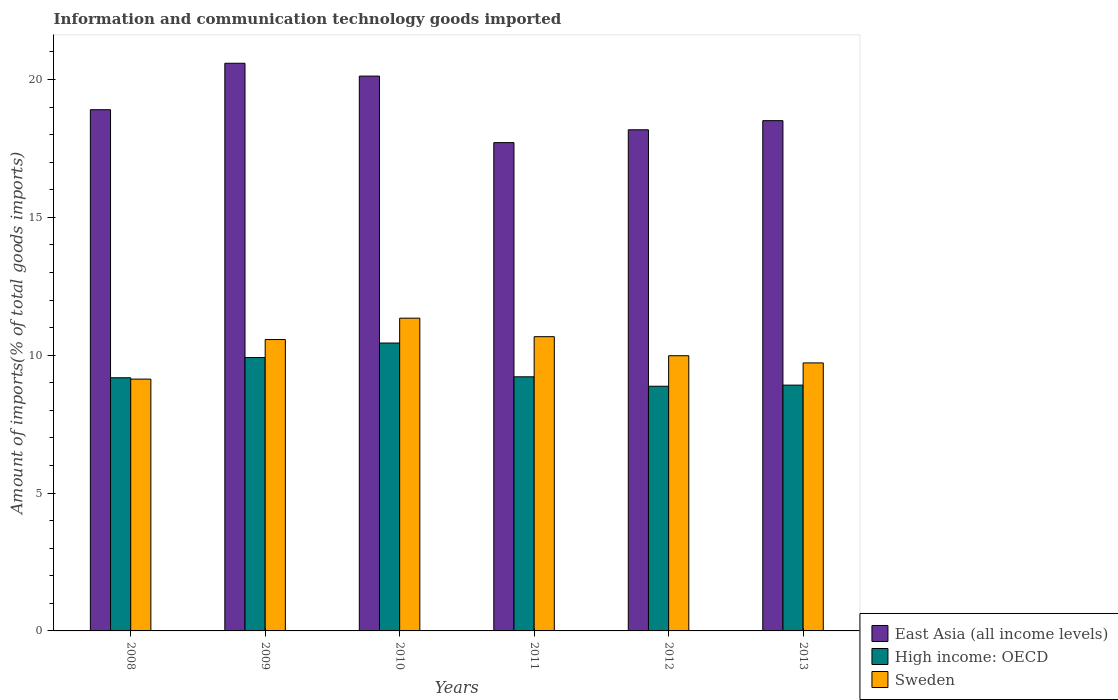How many groups of bars are there?
Offer a terse response. 6. Are the number of bars per tick equal to the number of legend labels?
Your answer should be compact. Yes. How many bars are there on the 2nd tick from the left?
Give a very brief answer. 3. What is the label of the 6th group of bars from the left?
Keep it short and to the point. 2013. In how many cases, is the number of bars for a given year not equal to the number of legend labels?
Provide a succinct answer. 0. What is the amount of goods imported in High income: OECD in 2013?
Offer a very short reply. 8.92. Across all years, what is the maximum amount of goods imported in Sweden?
Provide a succinct answer. 11.34. Across all years, what is the minimum amount of goods imported in High income: OECD?
Offer a very short reply. 8.87. In which year was the amount of goods imported in East Asia (all income levels) minimum?
Keep it short and to the point. 2011. What is the total amount of goods imported in High income: OECD in the graph?
Make the answer very short. 56.55. What is the difference between the amount of goods imported in Sweden in 2012 and that in 2013?
Make the answer very short. 0.26. What is the difference between the amount of goods imported in Sweden in 2011 and the amount of goods imported in High income: OECD in 2008?
Offer a very short reply. 1.49. What is the average amount of goods imported in Sweden per year?
Make the answer very short. 10.24. In the year 2013, what is the difference between the amount of goods imported in Sweden and amount of goods imported in East Asia (all income levels)?
Offer a very short reply. -8.79. In how many years, is the amount of goods imported in High income: OECD greater than 20 %?
Your answer should be compact. 0. What is the ratio of the amount of goods imported in East Asia (all income levels) in 2008 to that in 2011?
Provide a succinct answer. 1.07. Is the difference between the amount of goods imported in Sweden in 2011 and 2012 greater than the difference between the amount of goods imported in East Asia (all income levels) in 2011 and 2012?
Provide a short and direct response. Yes. What is the difference between the highest and the second highest amount of goods imported in East Asia (all income levels)?
Your response must be concise. 0.47. What is the difference between the highest and the lowest amount of goods imported in High income: OECD?
Provide a succinct answer. 1.57. What does the 1st bar from the left in 2010 represents?
Offer a very short reply. East Asia (all income levels). What does the 3rd bar from the right in 2012 represents?
Give a very brief answer. East Asia (all income levels). Is it the case that in every year, the sum of the amount of goods imported in High income: OECD and amount of goods imported in East Asia (all income levels) is greater than the amount of goods imported in Sweden?
Provide a succinct answer. Yes. Are all the bars in the graph horizontal?
Make the answer very short. No. How many years are there in the graph?
Give a very brief answer. 6. Does the graph contain grids?
Offer a very short reply. No. How many legend labels are there?
Your answer should be compact. 3. How are the legend labels stacked?
Offer a terse response. Vertical. What is the title of the graph?
Give a very brief answer. Information and communication technology goods imported. What is the label or title of the Y-axis?
Offer a very short reply. Amount of imports(% of total goods imports). What is the Amount of imports(% of total goods imports) of East Asia (all income levels) in 2008?
Your answer should be very brief. 18.9. What is the Amount of imports(% of total goods imports) of High income: OECD in 2008?
Provide a short and direct response. 9.18. What is the Amount of imports(% of total goods imports) in Sweden in 2008?
Your answer should be compact. 9.13. What is the Amount of imports(% of total goods imports) in East Asia (all income levels) in 2009?
Your response must be concise. 20.59. What is the Amount of imports(% of total goods imports) in High income: OECD in 2009?
Make the answer very short. 9.92. What is the Amount of imports(% of total goods imports) in Sweden in 2009?
Make the answer very short. 10.57. What is the Amount of imports(% of total goods imports) of East Asia (all income levels) in 2010?
Give a very brief answer. 20.12. What is the Amount of imports(% of total goods imports) in High income: OECD in 2010?
Offer a terse response. 10.44. What is the Amount of imports(% of total goods imports) in Sweden in 2010?
Your answer should be compact. 11.34. What is the Amount of imports(% of total goods imports) of East Asia (all income levels) in 2011?
Make the answer very short. 17.71. What is the Amount of imports(% of total goods imports) of High income: OECD in 2011?
Offer a terse response. 9.22. What is the Amount of imports(% of total goods imports) in Sweden in 2011?
Your answer should be compact. 10.67. What is the Amount of imports(% of total goods imports) of East Asia (all income levels) in 2012?
Your answer should be very brief. 18.18. What is the Amount of imports(% of total goods imports) in High income: OECD in 2012?
Your answer should be compact. 8.87. What is the Amount of imports(% of total goods imports) of Sweden in 2012?
Your response must be concise. 9.98. What is the Amount of imports(% of total goods imports) in East Asia (all income levels) in 2013?
Provide a succinct answer. 18.51. What is the Amount of imports(% of total goods imports) of High income: OECD in 2013?
Your response must be concise. 8.92. What is the Amount of imports(% of total goods imports) in Sweden in 2013?
Your answer should be compact. 9.72. Across all years, what is the maximum Amount of imports(% of total goods imports) in East Asia (all income levels)?
Provide a succinct answer. 20.59. Across all years, what is the maximum Amount of imports(% of total goods imports) in High income: OECD?
Give a very brief answer. 10.44. Across all years, what is the maximum Amount of imports(% of total goods imports) of Sweden?
Offer a terse response. 11.34. Across all years, what is the minimum Amount of imports(% of total goods imports) in East Asia (all income levels)?
Ensure brevity in your answer.  17.71. Across all years, what is the minimum Amount of imports(% of total goods imports) of High income: OECD?
Give a very brief answer. 8.87. Across all years, what is the minimum Amount of imports(% of total goods imports) in Sweden?
Make the answer very short. 9.13. What is the total Amount of imports(% of total goods imports) of East Asia (all income levels) in the graph?
Give a very brief answer. 114.02. What is the total Amount of imports(% of total goods imports) of High income: OECD in the graph?
Ensure brevity in your answer.  56.55. What is the total Amount of imports(% of total goods imports) of Sweden in the graph?
Provide a short and direct response. 61.42. What is the difference between the Amount of imports(% of total goods imports) of East Asia (all income levels) in 2008 and that in 2009?
Give a very brief answer. -1.68. What is the difference between the Amount of imports(% of total goods imports) of High income: OECD in 2008 and that in 2009?
Provide a succinct answer. -0.73. What is the difference between the Amount of imports(% of total goods imports) in Sweden in 2008 and that in 2009?
Offer a terse response. -1.44. What is the difference between the Amount of imports(% of total goods imports) in East Asia (all income levels) in 2008 and that in 2010?
Keep it short and to the point. -1.22. What is the difference between the Amount of imports(% of total goods imports) in High income: OECD in 2008 and that in 2010?
Make the answer very short. -1.26. What is the difference between the Amount of imports(% of total goods imports) of Sweden in 2008 and that in 2010?
Provide a short and direct response. -2.21. What is the difference between the Amount of imports(% of total goods imports) of East Asia (all income levels) in 2008 and that in 2011?
Offer a terse response. 1.19. What is the difference between the Amount of imports(% of total goods imports) of High income: OECD in 2008 and that in 2011?
Give a very brief answer. -0.03. What is the difference between the Amount of imports(% of total goods imports) of Sweden in 2008 and that in 2011?
Your answer should be compact. -1.54. What is the difference between the Amount of imports(% of total goods imports) in East Asia (all income levels) in 2008 and that in 2012?
Offer a terse response. 0.73. What is the difference between the Amount of imports(% of total goods imports) of High income: OECD in 2008 and that in 2012?
Your answer should be very brief. 0.31. What is the difference between the Amount of imports(% of total goods imports) in Sweden in 2008 and that in 2012?
Provide a short and direct response. -0.85. What is the difference between the Amount of imports(% of total goods imports) of East Asia (all income levels) in 2008 and that in 2013?
Keep it short and to the point. 0.4. What is the difference between the Amount of imports(% of total goods imports) in High income: OECD in 2008 and that in 2013?
Your answer should be very brief. 0.27. What is the difference between the Amount of imports(% of total goods imports) in Sweden in 2008 and that in 2013?
Give a very brief answer. -0.59. What is the difference between the Amount of imports(% of total goods imports) in East Asia (all income levels) in 2009 and that in 2010?
Offer a very short reply. 0.47. What is the difference between the Amount of imports(% of total goods imports) in High income: OECD in 2009 and that in 2010?
Your answer should be compact. -0.53. What is the difference between the Amount of imports(% of total goods imports) in Sweden in 2009 and that in 2010?
Offer a terse response. -0.78. What is the difference between the Amount of imports(% of total goods imports) of East Asia (all income levels) in 2009 and that in 2011?
Offer a very short reply. 2.88. What is the difference between the Amount of imports(% of total goods imports) of High income: OECD in 2009 and that in 2011?
Your response must be concise. 0.7. What is the difference between the Amount of imports(% of total goods imports) in Sweden in 2009 and that in 2011?
Your response must be concise. -0.1. What is the difference between the Amount of imports(% of total goods imports) in East Asia (all income levels) in 2009 and that in 2012?
Ensure brevity in your answer.  2.41. What is the difference between the Amount of imports(% of total goods imports) of High income: OECD in 2009 and that in 2012?
Your answer should be very brief. 1.04. What is the difference between the Amount of imports(% of total goods imports) in Sweden in 2009 and that in 2012?
Provide a short and direct response. 0.59. What is the difference between the Amount of imports(% of total goods imports) of East Asia (all income levels) in 2009 and that in 2013?
Provide a short and direct response. 2.08. What is the difference between the Amount of imports(% of total goods imports) in Sweden in 2009 and that in 2013?
Keep it short and to the point. 0.85. What is the difference between the Amount of imports(% of total goods imports) in East Asia (all income levels) in 2010 and that in 2011?
Make the answer very short. 2.41. What is the difference between the Amount of imports(% of total goods imports) in High income: OECD in 2010 and that in 2011?
Make the answer very short. 1.22. What is the difference between the Amount of imports(% of total goods imports) of Sweden in 2010 and that in 2011?
Provide a short and direct response. 0.67. What is the difference between the Amount of imports(% of total goods imports) of East Asia (all income levels) in 2010 and that in 2012?
Offer a terse response. 1.95. What is the difference between the Amount of imports(% of total goods imports) of High income: OECD in 2010 and that in 2012?
Offer a very short reply. 1.57. What is the difference between the Amount of imports(% of total goods imports) of Sweden in 2010 and that in 2012?
Provide a succinct answer. 1.36. What is the difference between the Amount of imports(% of total goods imports) of East Asia (all income levels) in 2010 and that in 2013?
Offer a terse response. 1.62. What is the difference between the Amount of imports(% of total goods imports) in High income: OECD in 2010 and that in 2013?
Give a very brief answer. 1.53. What is the difference between the Amount of imports(% of total goods imports) of Sweden in 2010 and that in 2013?
Ensure brevity in your answer.  1.62. What is the difference between the Amount of imports(% of total goods imports) in East Asia (all income levels) in 2011 and that in 2012?
Offer a very short reply. -0.47. What is the difference between the Amount of imports(% of total goods imports) in High income: OECD in 2011 and that in 2012?
Offer a terse response. 0.34. What is the difference between the Amount of imports(% of total goods imports) of Sweden in 2011 and that in 2012?
Offer a terse response. 0.69. What is the difference between the Amount of imports(% of total goods imports) in East Asia (all income levels) in 2011 and that in 2013?
Provide a succinct answer. -0.8. What is the difference between the Amount of imports(% of total goods imports) of High income: OECD in 2011 and that in 2013?
Make the answer very short. 0.3. What is the difference between the Amount of imports(% of total goods imports) in Sweden in 2011 and that in 2013?
Offer a terse response. 0.95. What is the difference between the Amount of imports(% of total goods imports) in East Asia (all income levels) in 2012 and that in 2013?
Make the answer very short. -0.33. What is the difference between the Amount of imports(% of total goods imports) in High income: OECD in 2012 and that in 2013?
Give a very brief answer. -0.04. What is the difference between the Amount of imports(% of total goods imports) of Sweden in 2012 and that in 2013?
Your answer should be compact. 0.26. What is the difference between the Amount of imports(% of total goods imports) of East Asia (all income levels) in 2008 and the Amount of imports(% of total goods imports) of High income: OECD in 2009?
Ensure brevity in your answer.  8.99. What is the difference between the Amount of imports(% of total goods imports) of East Asia (all income levels) in 2008 and the Amount of imports(% of total goods imports) of Sweden in 2009?
Make the answer very short. 8.34. What is the difference between the Amount of imports(% of total goods imports) in High income: OECD in 2008 and the Amount of imports(% of total goods imports) in Sweden in 2009?
Your answer should be compact. -1.39. What is the difference between the Amount of imports(% of total goods imports) of East Asia (all income levels) in 2008 and the Amount of imports(% of total goods imports) of High income: OECD in 2010?
Provide a succinct answer. 8.46. What is the difference between the Amount of imports(% of total goods imports) in East Asia (all income levels) in 2008 and the Amount of imports(% of total goods imports) in Sweden in 2010?
Your response must be concise. 7.56. What is the difference between the Amount of imports(% of total goods imports) in High income: OECD in 2008 and the Amount of imports(% of total goods imports) in Sweden in 2010?
Offer a very short reply. -2.16. What is the difference between the Amount of imports(% of total goods imports) in East Asia (all income levels) in 2008 and the Amount of imports(% of total goods imports) in High income: OECD in 2011?
Give a very brief answer. 9.69. What is the difference between the Amount of imports(% of total goods imports) of East Asia (all income levels) in 2008 and the Amount of imports(% of total goods imports) of Sweden in 2011?
Offer a very short reply. 8.23. What is the difference between the Amount of imports(% of total goods imports) in High income: OECD in 2008 and the Amount of imports(% of total goods imports) in Sweden in 2011?
Keep it short and to the point. -1.49. What is the difference between the Amount of imports(% of total goods imports) in East Asia (all income levels) in 2008 and the Amount of imports(% of total goods imports) in High income: OECD in 2012?
Offer a very short reply. 10.03. What is the difference between the Amount of imports(% of total goods imports) in East Asia (all income levels) in 2008 and the Amount of imports(% of total goods imports) in Sweden in 2012?
Keep it short and to the point. 8.92. What is the difference between the Amount of imports(% of total goods imports) of High income: OECD in 2008 and the Amount of imports(% of total goods imports) of Sweden in 2012?
Ensure brevity in your answer.  -0.8. What is the difference between the Amount of imports(% of total goods imports) of East Asia (all income levels) in 2008 and the Amount of imports(% of total goods imports) of High income: OECD in 2013?
Make the answer very short. 9.99. What is the difference between the Amount of imports(% of total goods imports) in East Asia (all income levels) in 2008 and the Amount of imports(% of total goods imports) in Sweden in 2013?
Offer a terse response. 9.18. What is the difference between the Amount of imports(% of total goods imports) in High income: OECD in 2008 and the Amount of imports(% of total goods imports) in Sweden in 2013?
Keep it short and to the point. -0.54. What is the difference between the Amount of imports(% of total goods imports) of East Asia (all income levels) in 2009 and the Amount of imports(% of total goods imports) of High income: OECD in 2010?
Make the answer very short. 10.15. What is the difference between the Amount of imports(% of total goods imports) in East Asia (all income levels) in 2009 and the Amount of imports(% of total goods imports) in Sweden in 2010?
Provide a short and direct response. 9.25. What is the difference between the Amount of imports(% of total goods imports) of High income: OECD in 2009 and the Amount of imports(% of total goods imports) of Sweden in 2010?
Give a very brief answer. -1.43. What is the difference between the Amount of imports(% of total goods imports) of East Asia (all income levels) in 2009 and the Amount of imports(% of total goods imports) of High income: OECD in 2011?
Your answer should be very brief. 11.37. What is the difference between the Amount of imports(% of total goods imports) of East Asia (all income levels) in 2009 and the Amount of imports(% of total goods imports) of Sweden in 2011?
Offer a terse response. 9.92. What is the difference between the Amount of imports(% of total goods imports) of High income: OECD in 2009 and the Amount of imports(% of total goods imports) of Sweden in 2011?
Provide a succinct answer. -0.76. What is the difference between the Amount of imports(% of total goods imports) of East Asia (all income levels) in 2009 and the Amount of imports(% of total goods imports) of High income: OECD in 2012?
Your answer should be very brief. 11.71. What is the difference between the Amount of imports(% of total goods imports) in East Asia (all income levels) in 2009 and the Amount of imports(% of total goods imports) in Sweden in 2012?
Offer a very short reply. 10.61. What is the difference between the Amount of imports(% of total goods imports) of High income: OECD in 2009 and the Amount of imports(% of total goods imports) of Sweden in 2012?
Offer a very short reply. -0.07. What is the difference between the Amount of imports(% of total goods imports) of East Asia (all income levels) in 2009 and the Amount of imports(% of total goods imports) of High income: OECD in 2013?
Ensure brevity in your answer.  11.67. What is the difference between the Amount of imports(% of total goods imports) of East Asia (all income levels) in 2009 and the Amount of imports(% of total goods imports) of Sweden in 2013?
Offer a terse response. 10.87. What is the difference between the Amount of imports(% of total goods imports) in High income: OECD in 2009 and the Amount of imports(% of total goods imports) in Sweden in 2013?
Ensure brevity in your answer.  0.19. What is the difference between the Amount of imports(% of total goods imports) of East Asia (all income levels) in 2010 and the Amount of imports(% of total goods imports) of High income: OECD in 2011?
Offer a terse response. 10.91. What is the difference between the Amount of imports(% of total goods imports) of East Asia (all income levels) in 2010 and the Amount of imports(% of total goods imports) of Sweden in 2011?
Ensure brevity in your answer.  9.45. What is the difference between the Amount of imports(% of total goods imports) of High income: OECD in 2010 and the Amount of imports(% of total goods imports) of Sweden in 2011?
Give a very brief answer. -0.23. What is the difference between the Amount of imports(% of total goods imports) in East Asia (all income levels) in 2010 and the Amount of imports(% of total goods imports) in High income: OECD in 2012?
Offer a terse response. 11.25. What is the difference between the Amount of imports(% of total goods imports) of East Asia (all income levels) in 2010 and the Amount of imports(% of total goods imports) of Sweden in 2012?
Keep it short and to the point. 10.14. What is the difference between the Amount of imports(% of total goods imports) of High income: OECD in 2010 and the Amount of imports(% of total goods imports) of Sweden in 2012?
Ensure brevity in your answer.  0.46. What is the difference between the Amount of imports(% of total goods imports) of East Asia (all income levels) in 2010 and the Amount of imports(% of total goods imports) of High income: OECD in 2013?
Provide a succinct answer. 11.21. What is the difference between the Amount of imports(% of total goods imports) in East Asia (all income levels) in 2010 and the Amount of imports(% of total goods imports) in Sweden in 2013?
Keep it short and to the point. 10.4. What is the difference between the Amount of imports(% of total goods imports) of High income: OECD in 2010 and the Amount of imports(% of total goods imports) of Sweden in 2013?
Ensure brevity in your answer.  0.72. What is the difference between the Amount of imports(% of total goods imports) in East Asia (all income levels) in 2011 and the Amount of imports(% of total goods imports) in High income: OECD in 2012?
Offer a terse response. 8.84. What is the difference between the Amount of imports(% of total goods imports) in East Asia (all income levels) in 2011 and the Amount of imports(% of total goods imports) in Sweden in 2012?
Ensure brevity in your answer.  7.73. What is the difference between the Amount of imports(% of total goods imports) in High income: OECD in 2011 and the Amount of imports(% of total goods imports) in Sweden in 2012?
Make the answer very short. -0.76. What is the difference between the Amount of imports(% of total goods imports) of East Asia (all income levels) in 2011 and the Amount of imports(% of total goods imports) of High income: OECD in 2013?
Provide a short and direct response. 8.8. What is the difference between the Amount of imports(% of total goods imports) of East Asia (all income levels) in 2011 and the Amount of imports(% of total goods imports) of Sweden in 2013?
Your answer should be compact. 7.99. What is the difference between the Amount of imports(% of total goods imports) in High income: OECD in 2011 and the Amount of imports(% of total goods imports) in Sweden in 2013?
Your answer should be compact. -0.5. What is the difference between the Amount of imports(% of total goods imports) in East Asia (all income levels) in 2012 and the Amount of imports(% of total goods imports) in High income: OECD in 2013?
Make the answer very short. 9.26. What is the difference between the Amount of imports(% of total goods imports) in East Asia (all income levels) in 2012 and the Amount of imports(% of total goods imports) in Sweden in 2013?
Your answer should be very brief. 8.46. What is the difference between the Amount of imports(% of total goods imports) in High income: OECD in 2012 and the Amount of imports(% of total goods imports) in Sweden in 2013?
Offer a very short reply. -0.85. What is the average Amount of imports(% of total goods imports) in East Asia (all income levels) per year?
Ensure brevity in your answer.  19. What is the average Amount of imports(% of total goods imports) in High income: OECD per year?
Keep it short and to the point. 9.42. What is the average Amount of imports(% of total goods imports) of Sweden per year?
Your answer should be very brief. 10.24. In the year 2008, what is the difference between the Amount of imports(% of total goods imports) in East Asia (all income levels) and Amount of imports(% of total goods imports) in High income: OECD?
Keep it short and to the point. 9.72. In the year 2008, what is the difference between the Amount of imports(% of total goods imports) in East Asia (all income levels) and Amount of imports(% of total goods imports) in Sweden?
Offer a very short reply. 9.77. In the year 2008, what is the difference between the Amount of imports(% of total goods imports) in High income: OECD and Amount of imports(% of total goods imports) in Sweden?
Provide a succinct answer. 0.05. In the year 2009, what is the difference between the Amount of imports(% of total goods imports) of East Asia (all income levels) and Amount of imports(% of total goods imports) of High income: OECD?
Offer a terse response. 10.67. In the year 2009, what is the difference between the Amount of imports(% of total goods imports) in East Asia (all income levels) and Amount of imports(% of total goods imports) in Sweden?
Your response must be concise. 10.02. In the year 2009, what is the difference between the Amount of imports(% of total goods imports) of High income: OECD and Amount of imports(% of total goods imports) of Sweden?
Offer a very short reply. -0.65. In the year 2010, what is the difference between the Amount of imports(% of total goods imports) in East Asia (all income levels) and Amount of imports(% of total goods imports) in High income: OECD?
Your response must be concise. 9.68. In the year 2010, what is the difference between the Amount of imports(% of total goods imports) of East Asia (all income levels) and Amount of imports(% of total goods imports) of Sweden?
Your response must be concise. 8.78. In the year 2010, what is the difference between the Amount of imports(% of total goods imports) in High income: OECD and Amount of imports(% of total goods imports) in Sweden?
Give a very brief answer. -0.9. In the year 2011, what is the difference between the Amount of imports(% of total goods imports) in East Asia (all income levels) and Amount of imports(% of total goods imports) in High income: OECD?
Offer a very short reply. 8.49. In the year 2011, what is the difference between the Amount of imports(% of total goods imports) of East Asia (all income levels) and Amount of imports(% of total goods imports) of Sweden?
Make the answer very short. 7.04. In the year 2011, what is the difference between the Amount of imports(% of total goods imports) in High income: OECD and Amount of imports(% of total goods imports) in Sweden?
Your answer should be compact. -1.46. In the year 2012, what is the difference between the Amount of imports(% of total goods imports) of East Asia (all income levels) and Amount of imports(% of total goods imports) of High income: OECD?
Offer a terse response. 9.3. In the year 2012, what is the difference between the Amount of imports(% of total goods imports) in East Asia (all income levels) and Amount of imports(% of total goods imports) in Sweden?
Your response must be concise. 8.2. In the year 2012, what is the difference between the Amount of imports(% of total goods imports) of High income: OECD and Amount of imports(% of total goods imports) of Sweden?
Your answer should be very brief. -1.11. In the year 2013, what is the difference between the Amount of imports(% of total goods imports) in East Asia (all income levels) and Amount of imports(% of total goods imports) in High income: OECD?
Your response must be concise. 9.59. In the year 2013, what is the difference between the Amount of imports(% of total goods imports) in East Asia (all income levels) and Amount of imports(% of total goods imports) in Sweden?
Make the answer very short. 8.79. In the year 2013, what is the difference between the Amount of imports(% of total goods imports) in High income: OECD and Amount of imports(% of total goods imports) in Sweden?
Keep it short and to the point. -0.81. What is the ratio of the Amount of imports(% of total goods imports) of East Asia (all income levels) in 2008 to that in 2009?
Your answer should be very brief. 0.92. What is the ratio of the Amount of imports(% of total goods imports) of High income: OECD in 2008 to that in 2009?
Offer a terse response. 0.93. What is the ratio of the Amount of imports(% of total goods imports) of Sweden in 2008 to that in 2009?
Your answer should be very brief. 0.86. What is the ratio of the Amount of imports(% of total goods imports) in East Asia (all income levels) in 2008 to that in 2010?
Your answer should be very brief. 0.94. What is the ratio of the Amount of imports(% of total goods imports) of High income: OECD in 2008 to that in 2010?
Your response must be concise. 0.88. What is the ratio of the Amount of imports(% of total goods imports) of Sweden in 2008 to that in 2010?
Provide a succinct answer. 0.81. What is the ratio of the Amount of imports(% of total goods imports) of East Asia (all income levels) in 2008 to that in 2011?
Make the answer very short. 1.07. What is the ratio of the Amount of imports(% of total goods imports) in Sweden in 2008 to that in 2011?
Ensure brevity in your answer.  0.86. What is the ratio of the Amount of imports(% of total goods imports) in East Asia (all income levels) in 2008 to that in 2012?
Offer a very short reply. 1.04. What is the ratio of the Amount of imports(% of total goods imports) of High income: OECD in 2008 to that in 2012?
Offer a very short reply. 1.03. What is the ratio of the Amount of imports(% of total goods imports) of Sweden in 2008 to that in 2012?
Ensure brevity in your answer.  0.92. What is the ratio of the Amount of imports(% of total goods imports) in East Asia (all income levels) in 2008 to that in 2013?
Your answer should be very brief. 1.02. What is the ratio of the Amount of imports(% of total goods imports) in High income: OECD in 2008 to that in 2013?
Your answer should be very brief. 1.03. What is the ratio of the Amount of imports(% of total goods imports) of Sweden in 2008 to that in 2013?
Offer a terse response. 0.94. What is the ratio of the Amount of imports(% of total goods imports) in East Asia (all income levels) in 2009 to that in 2010?
Make the answer very short. 1.02. What is the ratio of the Amount of imports(% of total goods imports) in High income: OECD in 2009 to that in 2010?
Provide a succinct answer. 0.95. What is the ratio of the Amount of imports(% of total goods imports) in Sweden in 2009 to that in 2010?
Provide a short and direct response. 0.93. What is the ratio of the Amount of imports(% of total goods imports) of East Asia (all income levels) in 2009 to that in 2011?
Keep it short and to the point. 1.16. What is the ratio of the Amount of imports(% of total goods imports) of High income: OECD in 2009 to that in 2011?
Your answer should be very brief. 1.08. What is the ratio of the Amount of imports(% of total goods imports) in Sweden in 2009 to that in 2011?
Provide a short and direct response. 0.99. What is the ratio of the Amount of imports(% of total goods imports) of East Asia (all income levels) in 2009 to that in 2012?
Give a very brief answer. 1.13. What is the ratio of the Amount of imports(% of total goods imports) of High income: OECD in 2009 to that in 2012?
Ensure brevity in your answer.  1.12. What is the ratio of the Amount of imports(% of total goods imports) of Sweden in 2009 to that in 2012?
Ensure brevity in your answer.  1.06. What is the ratio of the Amount of imports(% of total goods imports) in East Asia (all income levels) in 2009 to that in 2013?
Give a very brief answer. 1.11. What is the ratio of the Amount of imports(% of total goods imports) of High income: OECD in 2009 to that in 2013?
Make the answer very short. 1.11. What is the ratio of the Amount of imports(% of total goods imports) of Sweden in 2009 to that in 2013?
Provide a succinct answer. 1.09. What is the ratio of the Amount of imports(% of total goods imports) of East Asia (all income levels) in 2010 to that in 2011?
Keep it short and to the point. 1.14. What is the ratio of the Amount of imports(% of total goods imports) in High income: OECD in 2010 to that in 2011?
Your response must be concise. 1.13. What is the ratio of the Amount of imports(% of total goods imports) in Sweden in 2010 to that in 2011?
Your answer should be very brief. 1.06. What is the ratio of the Amount of imports(% of total goods imports) of East Asia (all income levels) in 2010 to that in 2012?
Provide a succinct answer. 1.11. What is the ratio of the Amount of imports(% of total goods imports) in High income: OECD in 2010 to that in 2012?
Your answer should be compact. 1.18. What is the ratio of the Amount of imports(% of total goods imports) of Sweden in 2010 to that in 2012?
Your answer should be compact. 1.14. What is the ratio of the Amount of imports(% of total goods imports) in East Asia (all income levels) in 2010 to that in 2013?
Your response must be concise. 1.09. What is the ratio of the Amount of imports(% of total goods imports) in High income: OECD in 2010 to that in 2013?
Your response must be concise. 1.17. What is the ratio of the Amount of imports(% of total goods imports) of Sweden in 2010 to that in 2013?
Your response must be concise. 1.17. What is the ratio of the Amount of imports(% of total goods imports) of East Asia (all income levels) in 2011 to that in 2012?
Keep it short and to the point. 0.97. What is the ratio of the Amount of imports(% of total goods imports) of High income: OECD in 2011 to that in 2012?
Your response must be concise. 1.04. What is the ratio of the Amount of imports(% of total goods imports) of Sweden in 2011 to that in 2012?
Your answer should be very brief. 1.07. What is the ratio of the Amount of imports(% of total goods imports) of East Asia (all income levels) in 2011 to that in 2013?
Make the answer very short. 0.96. What is the ratio of the Amount of imports(% of total goods imports) in High income: OECD in 2011 to that in 2013?
Provide a succinct answer. 1.03. What is the ratio of the Amount of imports(% of total goods imports) in Sweden in 2011 to that in 2013?
Your answer should be very brief. 1.1. What is the ratio of the Amount of imports(% of total goods imports) of East Asia (all income levels) in 2012 to that in 2013?
Give a very brief answer. 0.98. What is the ratio of the Amount of imports(% of total goods imports) in High income: OECD in 2012 to that in 2013?
Your response must be concise. 1. What is the ratio of the Amount of imports(% of total goods imports) in Sweden in 2012 to that in 2013?
Make the answer very short. 1.03. What is the difference between the highest and the second highest Amount of imports(% of total goods imports) in East Asia (all income levels)?
Ensure brevity in your answer.  0.47. What is the difference between the highest and the second highest Amount of imports(% of total goods imports) in High income: OECD?
Give a very brief answer. 0.53. What is the difference between the highest and the second highest Amount of imports(% of total goods imports) of Sweden?
Provide a succinct answer. 0.67. What is the difference between the highest and the lowest Amount of imports(% of total goods imports) in East Asia (all income levels)?
Provide a succinct answer. 2.88. What is the difference between the highest and the lowest Amount of imports(% of total goods imports) in High income: OECD?
Your answer should be very brief. 1.57. What is the difference between the highest and the lowest Amount of imports(% of total goods imports) in Sweden?
Give a very brief answer. 2.21. 